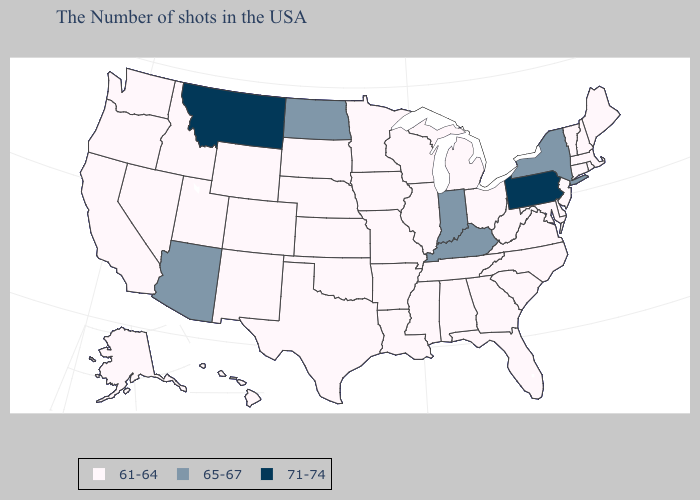What is the lowest value in the Northeast?
Concise answer only. 61-64. Name the states that have a value in the range 65-67?
Give a very brief answer. New York, Kentucky, Indiana, North Dakota, Arizona. What is the lowest value in states that border Utah?
Short answer required. 61-64. Name the states that have a value in the range 71-74?
Concise answer only. Pennsylvania, Montana. Name the states that have a value in the range 61-64?
Be succinct. Maine, Massachusetts, Rhode Island, New Hampshire, Vermont, Connecticut, New Jersey, Delaware, Maryland, Virginia, North Carolina, South Carolina, West Virginia, Ohio, Florida, Georgia, Michigan, Alabama, Tennessee, Wisconsin, Illinois, Mississippi, Louisiana, Missouri, Arkansas, Minnesota, Iowa, Kansas, Nebraska, Oklahoma, Texas, South Dakota, Wyoming, Colorado, New Mexico, Utah, Idaho, Nevada, California, Washington, Oregon, Alaska, Hawaii. Does Kentucky have the lowest value in the USA?
Answer briefly. No. Name the states that have a value in the range 71-74?
Be succinct. Pennsylvania, Montana. What is the value of Illinois?
Give a very brief answer. 61-64. Does Montana have the highest value in the West?
Be succinct. Yes. What is the value of Louisiana?
Be succinct. 61-64. What is the lowest value in states that border Iowa?
Short answer required. 61-64. Does the first symbol in the legend represent the smallest category?
Concise answer only. Yes. Does Pennsylvania have the highest value in the USA?
Be succinct. Yes. Among the states that border New Hampshire , which have the lowest value?
Give a very brief answer. Maine, Massachusetts, Vermont. 